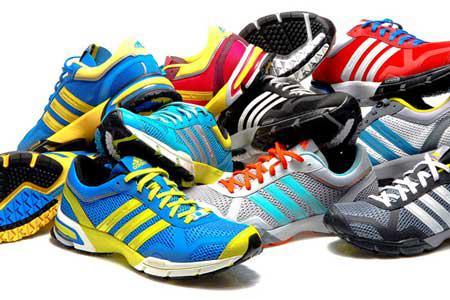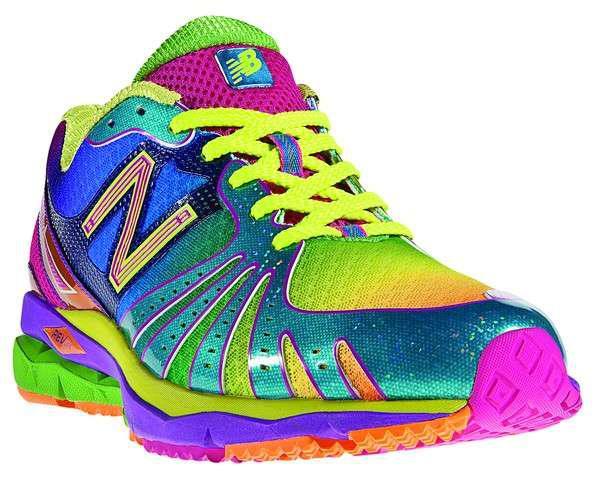The first image is the image on the left, the second image is the image on the right. Evaluate the accuracy of this statement regarding the images: "At least one image shows exactly one pair of shoes.". Is it true? Answer yes or no. No. 